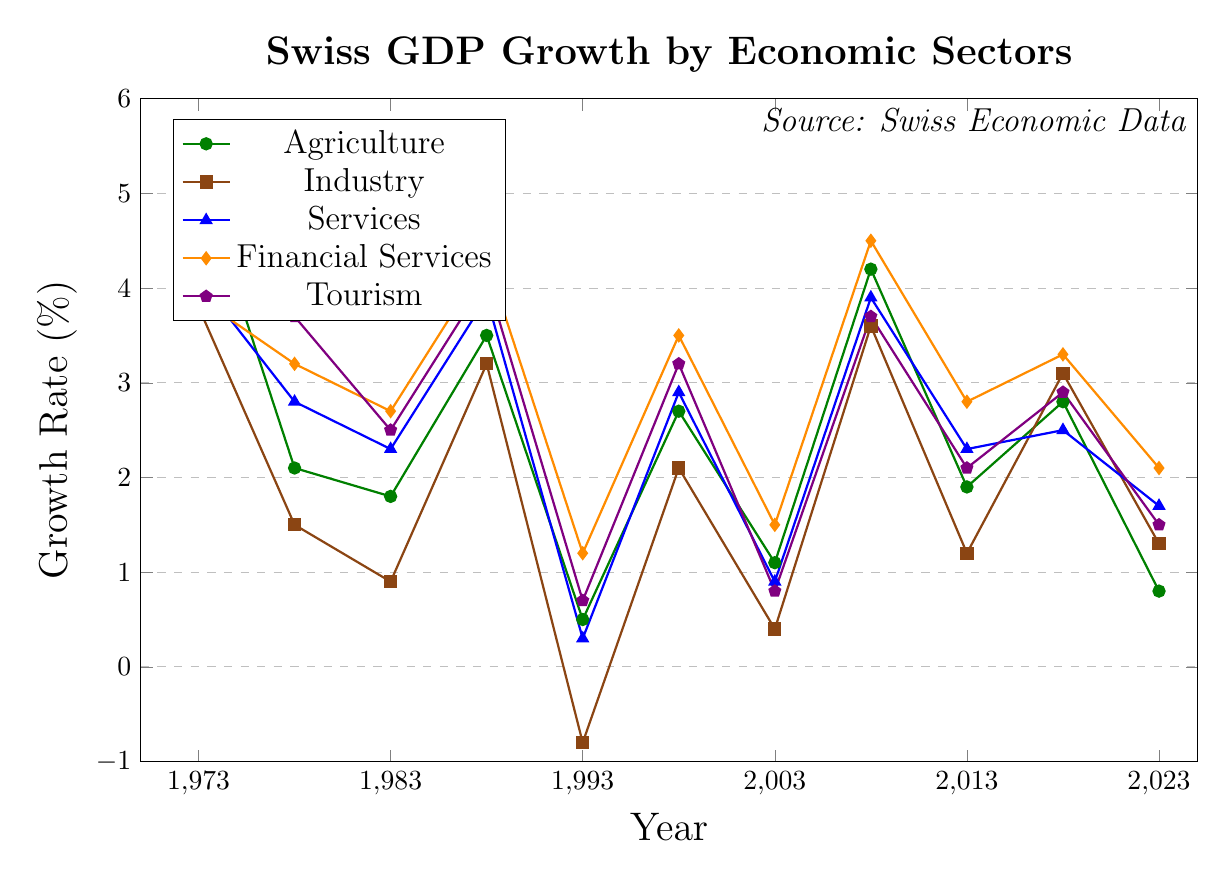What's the highest recorded growth rate for Financial Services over the 50 years? Look at the points on the Financial Services line (orange) and find the highest value, which occurs in 2008 at 4.5%
Answer: 4.5% Which sector experienced negative growth, and in which year did it occur? Identify the line with a negative value. The Industry sector (brown) experienced a negative growth rate in 1993 at -0.8%
Answer: Industry, 1993 Between 1973 and 1983, which sector had the steepest decline in growth rate? Compare the differences in growth rates between 1973 and 1983 for each sector. Agriculture dropped by 3.4% (5.2 to 1.8), making it the steepest decline
Answer: Agriculture Which two sectors have very similar growth rates in 2018, and what are those rates? Locate 2018 on the x-axis and find the points for each sector. Services and Tourism have similar rates of 2.5% and 2.9% respectively
Answer: Services (2.5%), Tourism (2.9%) How did the growth rate for Agriculture change from 2008 to 2013? Observe the Agriculture line (green) from 2008 (4.2%) to 2013 (1.9%). The growth rate decreased by 2.3%
Answer: Decreased by 2.3% What's the average growth rate for Industry from 1983 to 2023? Average the values of Industry from 1983 (0.9), 1988 (3.2), 1993 (-0.8), 1998 (2.1), 2003 (0.4), 2008 (3.6), 2013 (1.2), 2018 (3.1), 2023 (1.3). The total is 15 / 9 = 1.67%
Answer: 1.67% Which sector showed the most consistent growth over time? Visually inspect the lines for volatility. Financial Services (orange) shows relatively smooth and consistent growth patterns without sharp changes
Answer: Financial Services In 2003, how did the growth rates of Agriculture and Tourism compare? Locate 2003 on the x-axis. Agriculture (green) is at 1.1%, and Tourism (purple) is 0.8%. Agriculture was higher by 0.3%
Answer: Agriculture was higher by 0.3% What is the difference in growth rates between Services and Financial Services in 2013? Look at the 2013 values for Services (blue, 2.3%) and Financial Services (orange, 2.8%). The difference is 2.8% - 2.3% = 0.5%
Answer: 0.5% Which year did all sectors show a positive growth rate after the previous year’s recession in 1993? Notice that in 1998, all sectors' growth rates returned to positive values: Agriculture (2.7%), Industry (2.1%), Services (2.9%), Financial Services (3.5%), and Tourism (3.2%)
Answer: 1998 